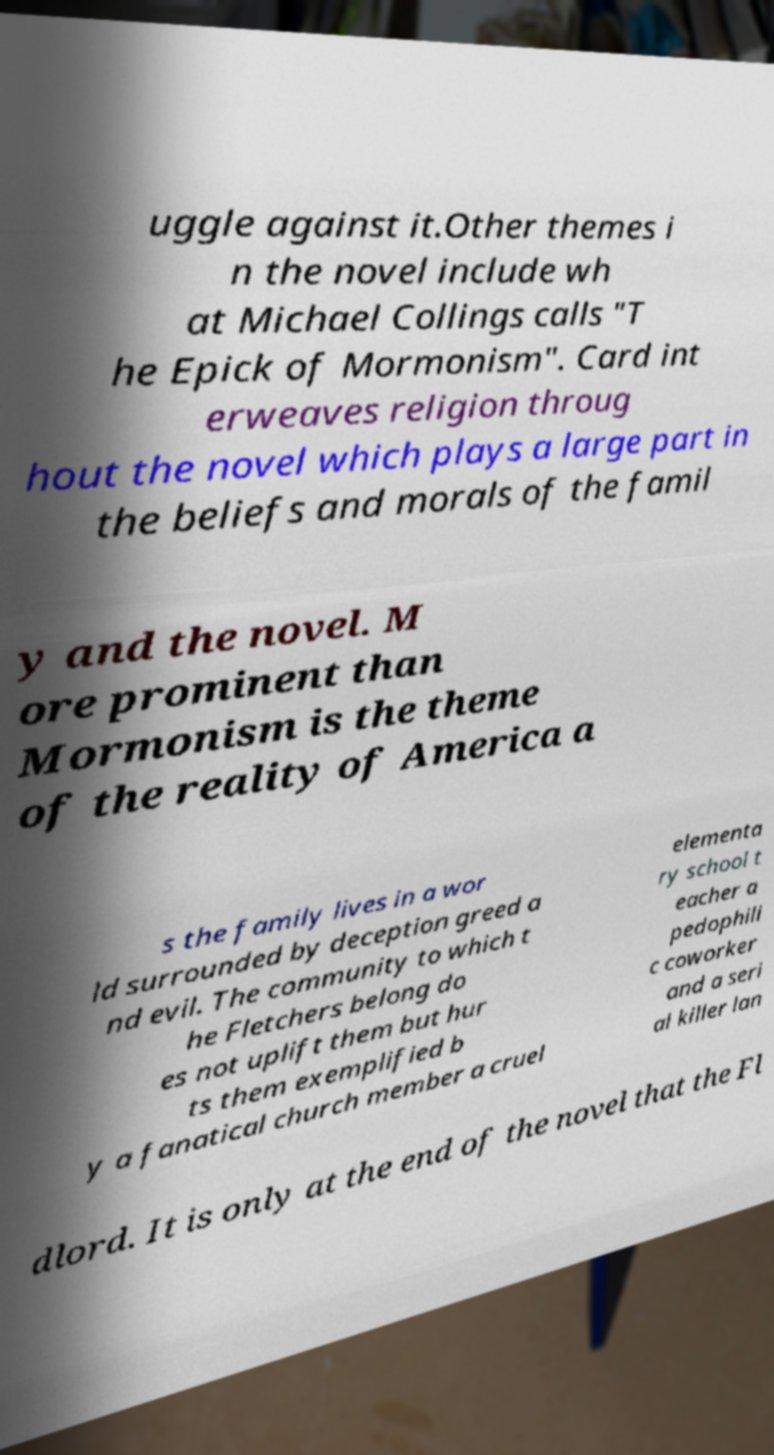What messages or text are displayed in this image? I need them in a readable, typed format. uggle against it.Other themes i n the novel include wh at Michael Collings calls "T he Epick of Mormonism". Card int erweaves religion throug hout the novel which plays a large part in the beliefs and morals of the famil y and the novel. M ore prominent than Mormonism is the theme of the reality of America a s the family lives in a wor ld surrounded by deception greed a nd evil. The community to which t he Fletchers belong do es not uplift them but hur ts them exemplified b y a fanatical church member a cruel elementa ry school t eacher a pedophili c coworker and a seri al killer lan dlord. It is only at the end of the novel that the Fl 